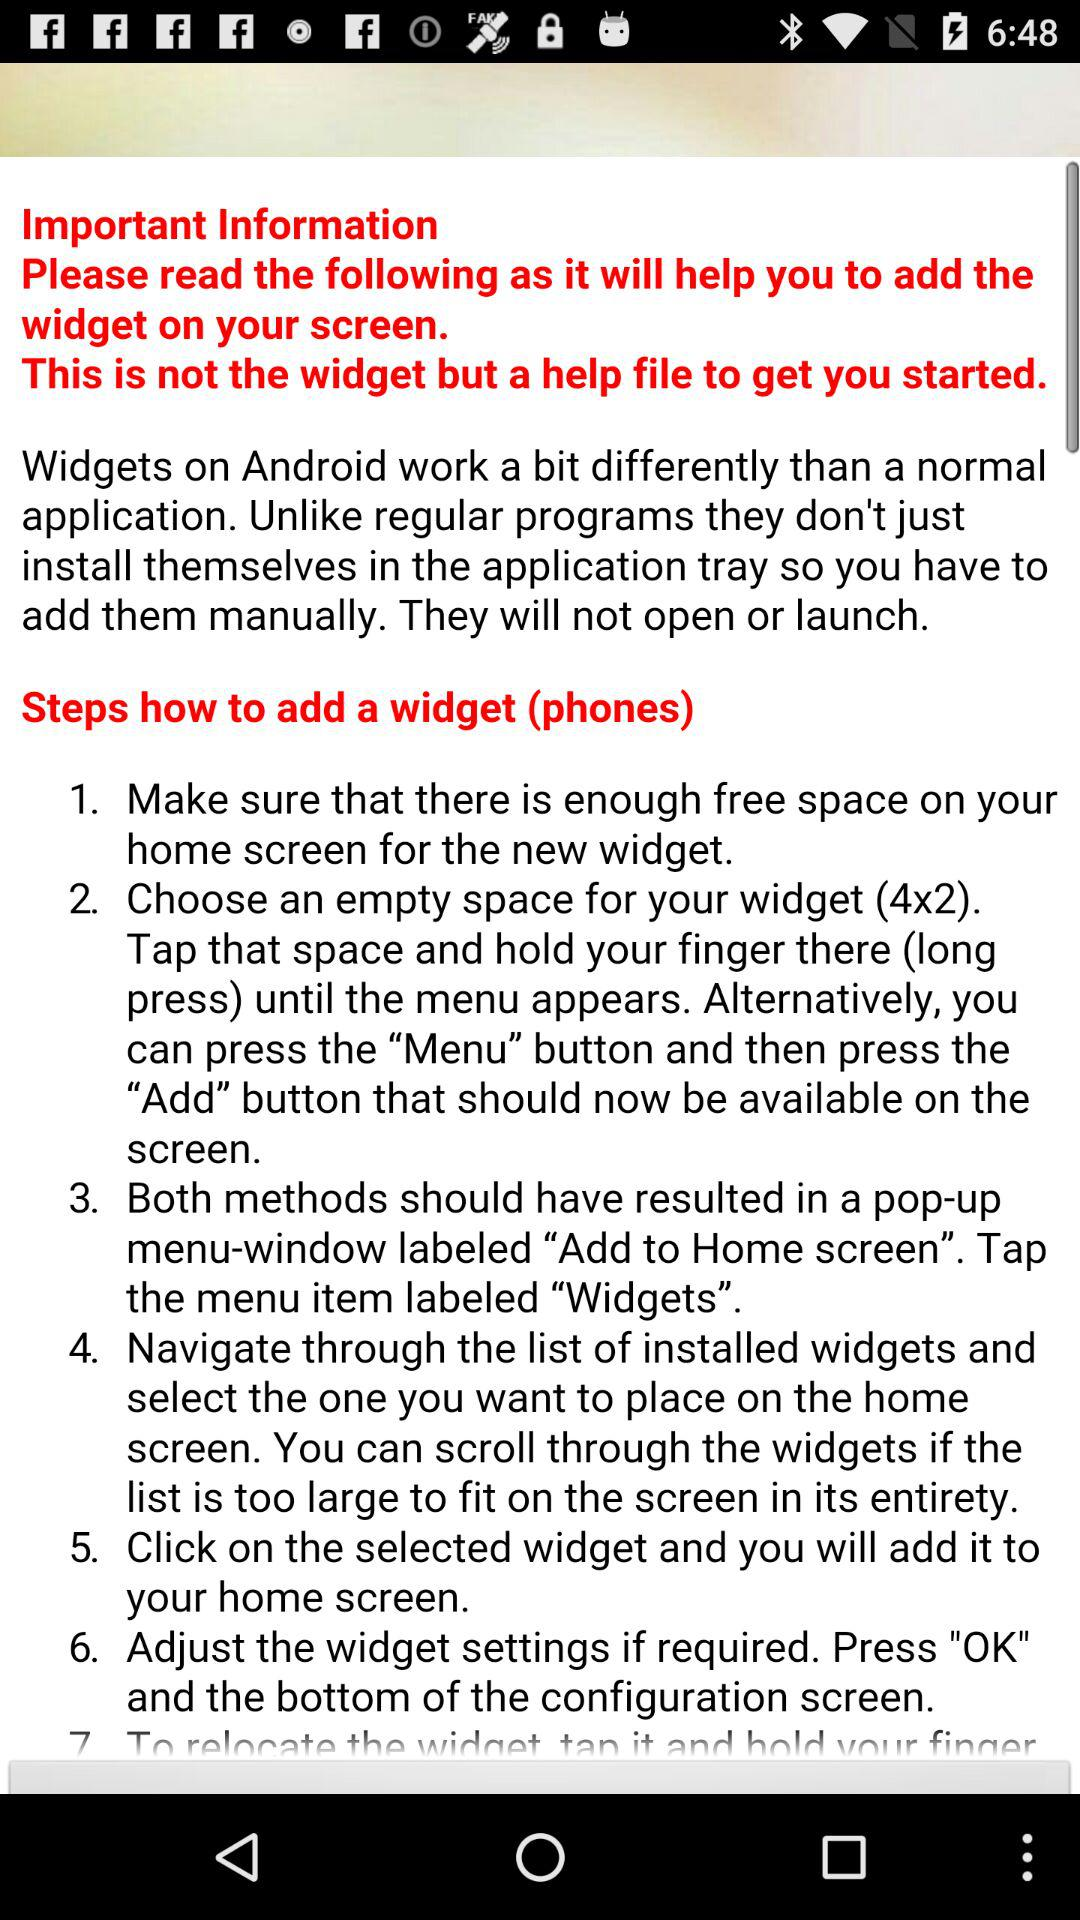How many steps are there in the instructions for adding a widget?
Answer the question using a single word or phrase. 7 